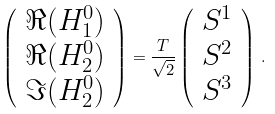<formula> <loc_0><loc_0><loc_500><loc_500>\left ( \begin{array} { c } \Re ( H _ { 1 } ^ { 0 } ) \\ \Re ( H _ { 2 } ^ { 0 } ) \\ \Im ( H _ { 2 } ^ { 0 } ) \end{array} \right ) = \frac { T } { \sqrt { 2 } } \left ( \begin{array} { c } S ^ { 1 } \\ S ^ { 2 } \\ S ^ { 3 } \end{array} \right ) \, .</formula> 